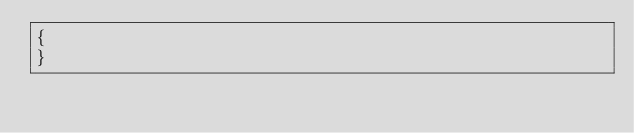Convert code to text. <code><loc_0><loc_0><loc_500><loc_500><_PHP_>{
}
</code> 